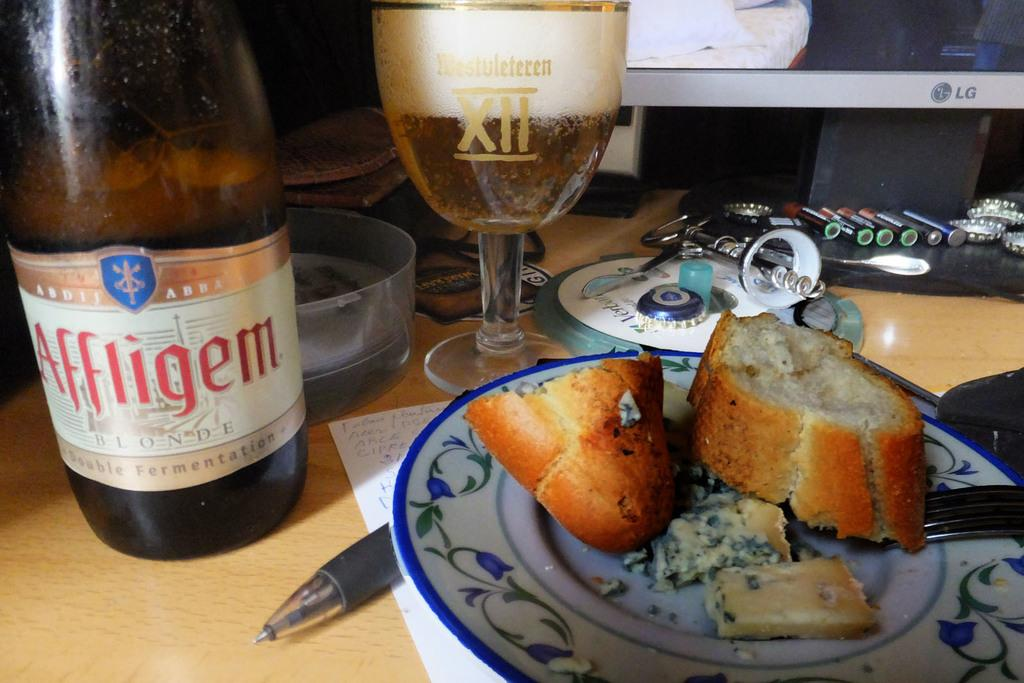<image>
Describe the image concisely. the word Affligem is on a bottle next to a plate 